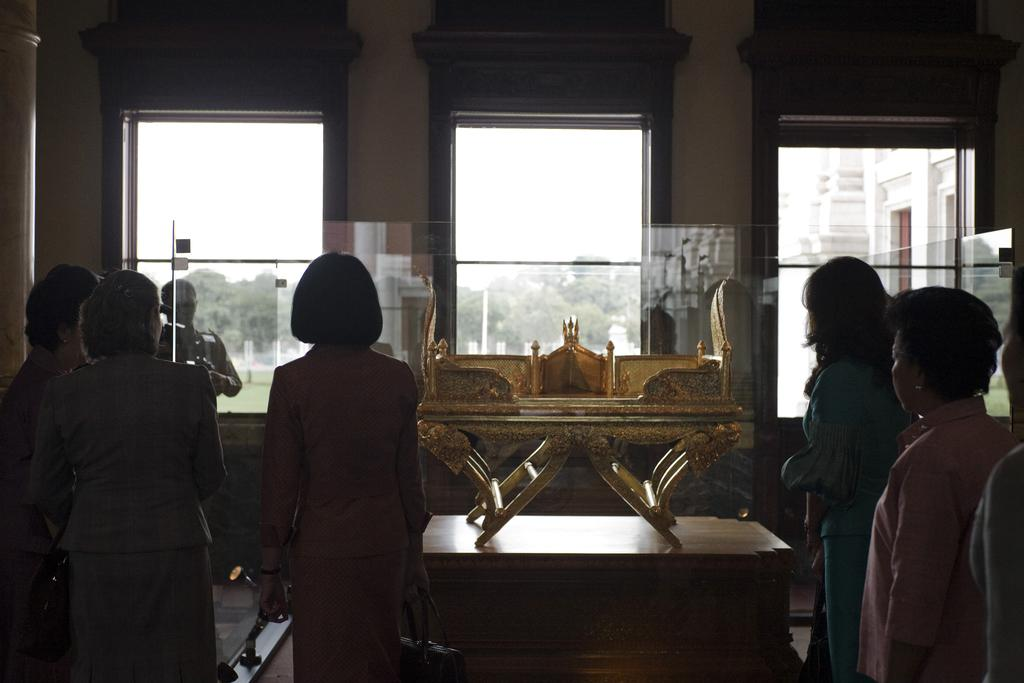What are the people in the image doing? The persons standing on the floor are likely engaged in some activity or conversation. What is the primary object in the image? There is a table in the image. What can be seen through the windows in the image? Trees and the sky are visible through the windows. What type of cabbage is being stored in the basket in the image? There is no basket or cabbage present in the image. What color is the vest worn by the person in the image? There is no person wearing a vest in the image. 